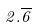<formula> <loc_0><loc_0><loc_500><loc_500>2 . \overline { 6 }</formula> 